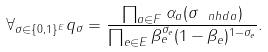Convert formula to latex. <formula><loc_0><loc_0><loc_500><loc_500>\forall _ { \sigma \in \{ 0 , 1 \} ^ { E } } q _ { \sigma } = \frac { \prod _ { a \in F } \alpha _ { a } ( \sigma _ { \ n h d a } ) } { \prod _ { e \in E } \beta _ { e } ^ { \sigma _ { e } } ( 1 - \beta _ { e } ) ^ { 1 - \sigma _ { e } } } .</formula> 